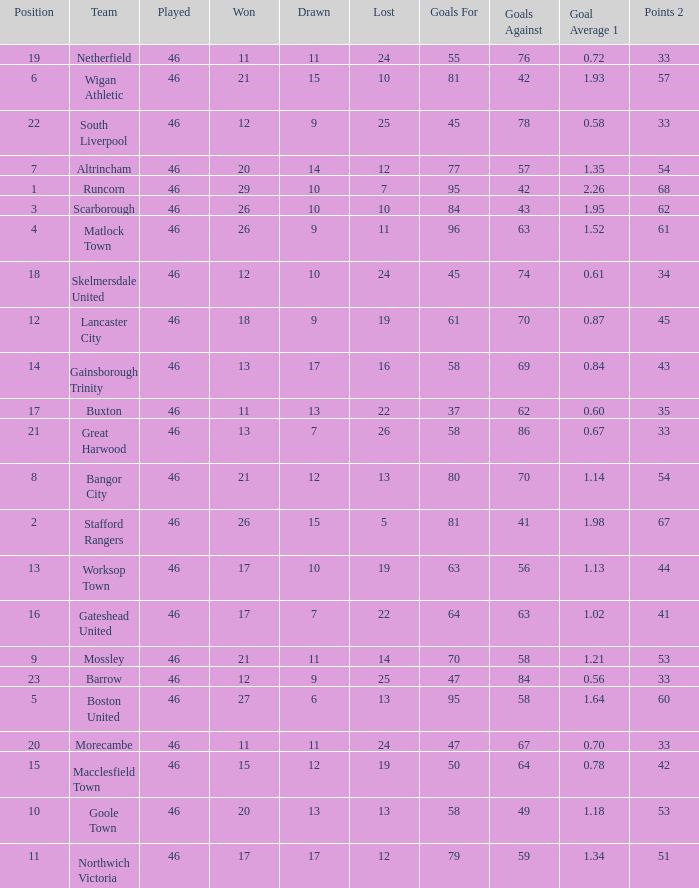How many times did the Lancaster City team play? 1.0. Can you give me this table as a dict? {'header': ['Position', 'Team', 'Played', 'Won', 'Drawn', 'Lost', 'Goals For', 'Goals Against', 'Goal Average 1', 'Points 2'], 'rows': [['19', 'Netherfield', '46', '11', '11', '24', '55', '76', '0.72', '33'], ['6', 'Wigan Athletic', '46', '21', '15', '10', '81', '42', '1.93', '57'], ['22', 'South Liverpool', '46', '12', '9', '25', '45', '78', '0.58', '33'], ['7', 'Altrincham', '46', '20', '14', '12', '77', '57', '1.35', '54'], ['1', 'Runcorn', '46', '29', '10', '7', '95', '42', '2.26', '68'], ['3', 'Scarborough', '46', '26', '10', '10', '84', '43', '1.95', '62'], ['4', 'Matlock Town', '46', '26', '9', '11', '96', '63', '1.52', '61'], ['18', 'Skelmersdale United', '46', '12', '10', '24', '45', '74', '0.61', '34'], ['12', 'Lancaster City', '46', '18', '9', '19', '61', '70', '0.87', '45'], ['14', 'Gainsborough Trinity', '46', '13', '17', '16', '58', '69', '0.84', '43'], ['17', 'Buxton', '46', '11', '13', '22', '37', '62', '0.60', '35'], ['21', 'Great Harwood', '46', '13', '7', '26', '58', '86', '0.67', '33'], ['8', 'Bangor City', '46', '21', '12', '13', '80', '70', '1.14', '54'], ['2', 'Stafford Rangers', '46', '26', '15', '5', '81', '41', '1.98', '67'], ['13', 'Worksop Town', '46', '17', '10', '19', '63', '56', '1.13', '44'], ['16', 'Gateshead United', '46', '17', '7', '22', '64', '63', '1.02', '41'], ['9', 'Mossley', '46', '21', '11', '14', '70', '58', '1.21', '53'], ['23', 'Barrow', '46', '12', '9', '25', '47', '84', '0.56', '33'], ['5', 'Boston United', '46', '27', '6', '13', '95', '58', '1.64', '60'], ['20', 'Morecambe', '46', '11', '11', '24', '47', '67', '0.70', '33'], ['15', 'Macclesfield Town', '46', '15', '12', '19', '50', '64', '0.78', '42'], ['10', 'Goole Town', '46', '20', '13', '13', '58', '49', '1.18', '53'], ['11', 'Northwich Victoria', '46', '17', '17', '12', '79', '59', '1.34', '51']]} 